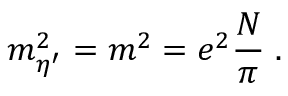<formula> <loc_0><loc_0><loc_500><loc_500>m _ { \eta ^ { \prime } } ^ { 2 } = m ^ { 2 } = e ^ { 2 } \frac { N } { \pi } \, .</formula> 